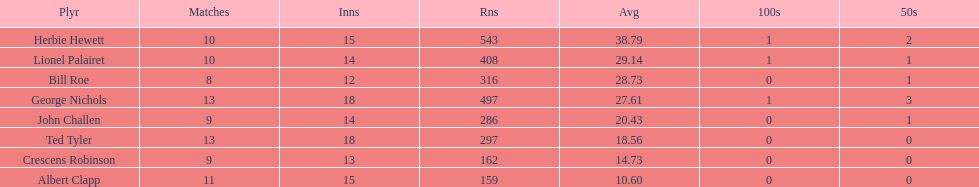How many innings did bill and ted have in total? 30. 